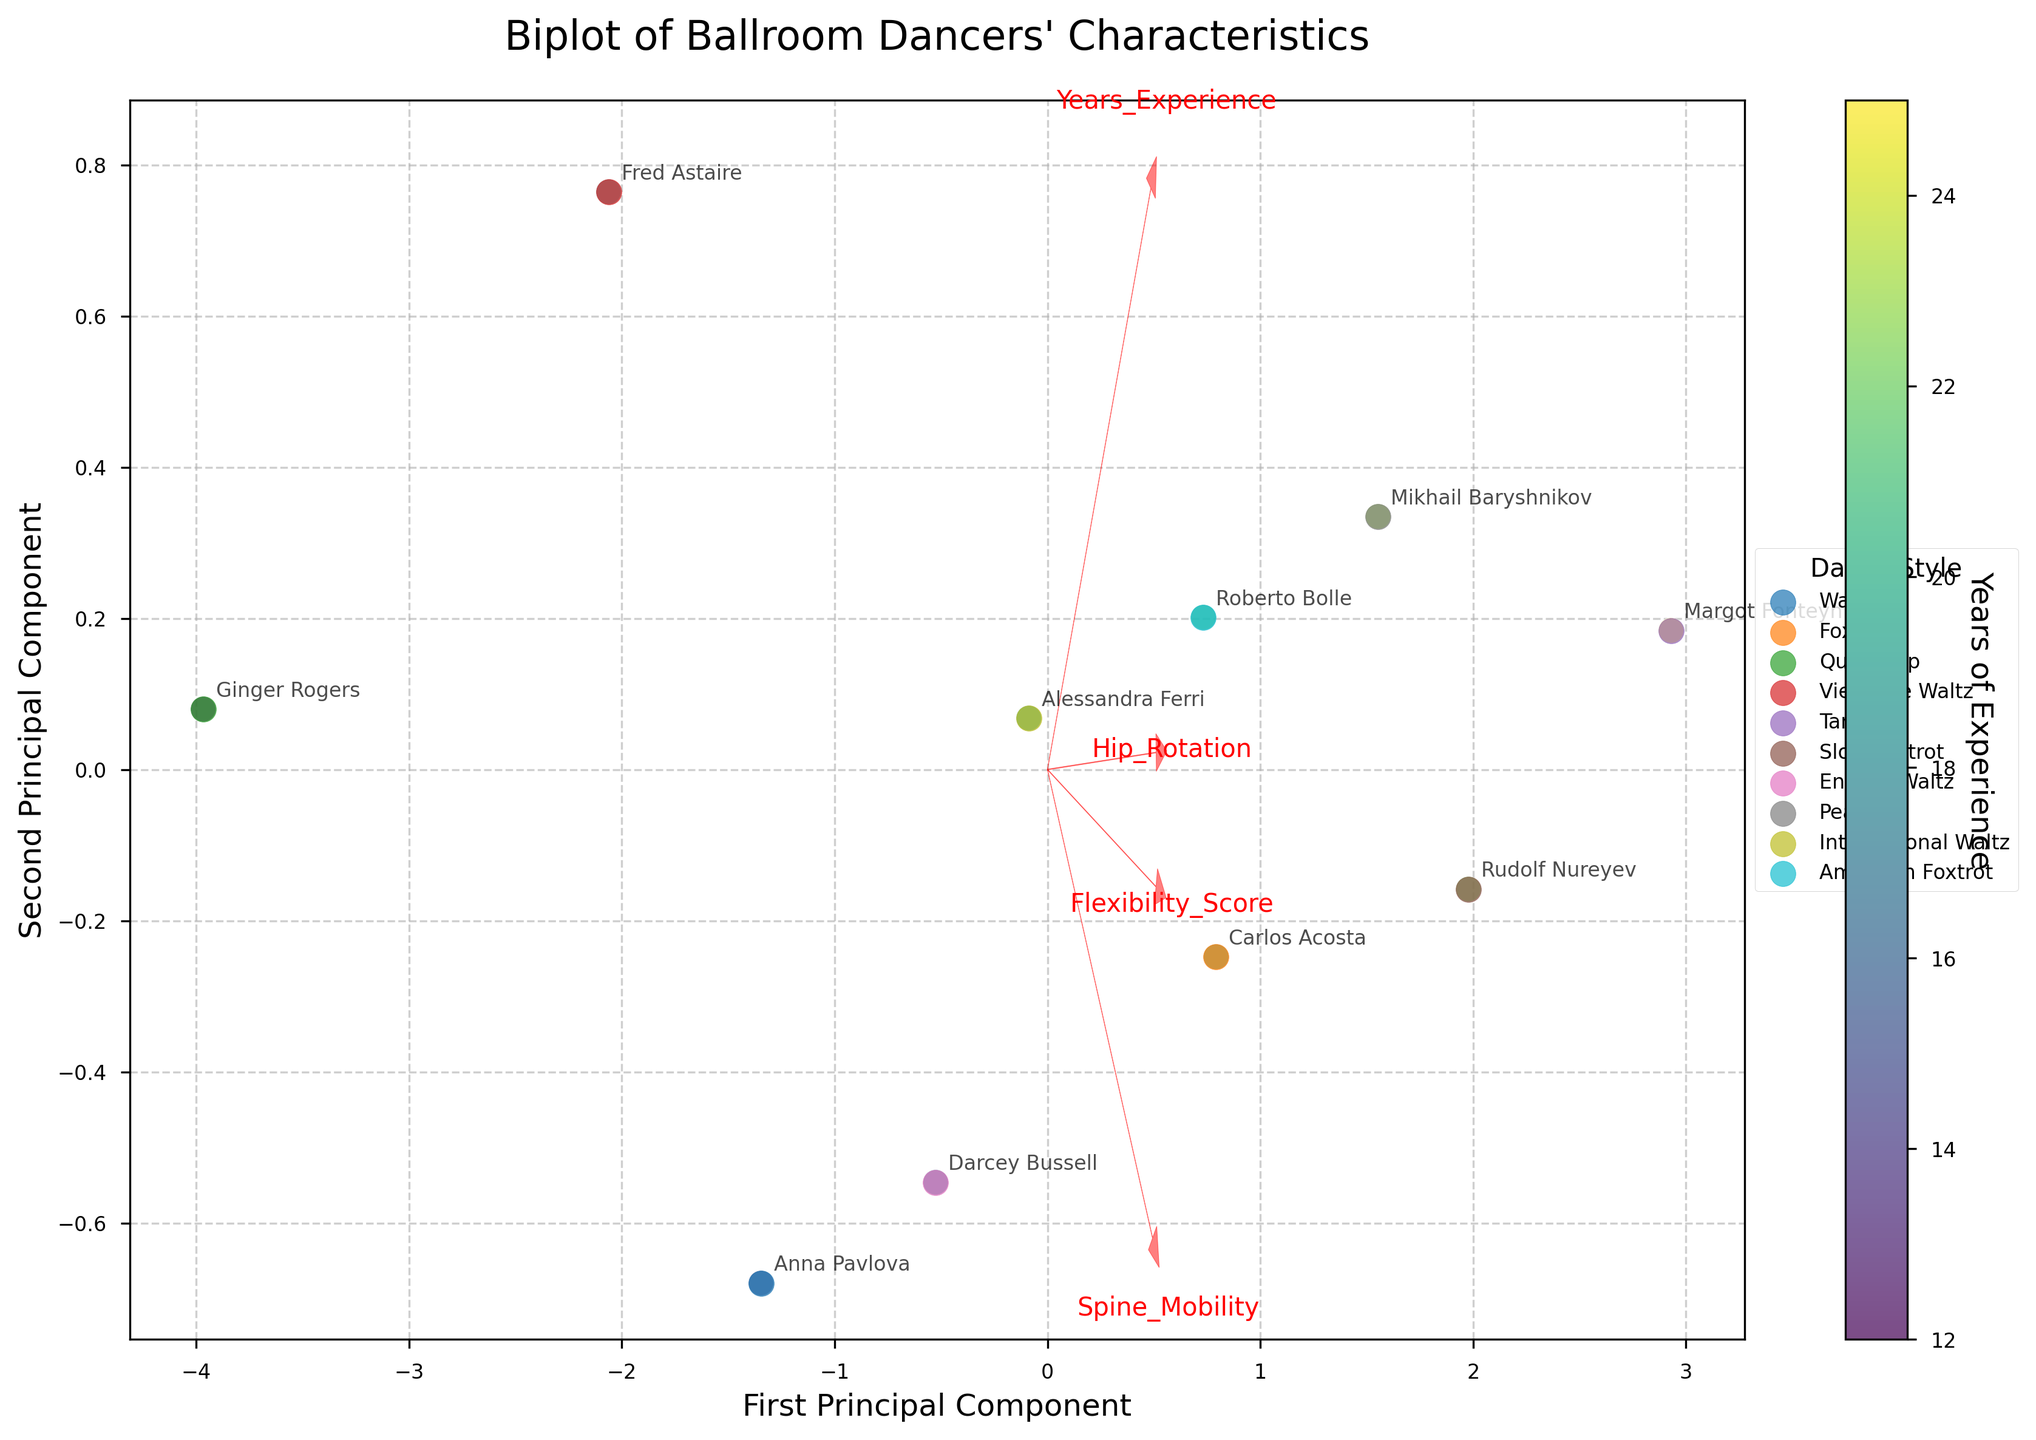How many dance styles are represented in the biplot? The legend on the right side of the biplot shows unique labels for dance styles. By counting these unique labels, we can determine the number of dance styles represented.
Answer: 10 What does the color of the scatter points represent? The colorbar label indicates that the colors represent the "Years of Experience" of the dancers.
Answer: Years of Experience Which principal component axis explains more variance? The x-axis is labeled as "First Principal Component," and this suggests it explains more variance compared to the "Second Principal Component" on the y-axis.
Answer: First Principal Component Whose flexibility score is plotted highest along the first principal component? The annotations near the highest point on the x-axis (First Principal Component) should identify the dancer.
Answer: Margot Fonteyn What do the red arrows represent in the biplot? The arrows are labeled with features such as "Years_Experience," "Flexibility_Score," "Hip_Rotation," and "Spine_Mobility;" they show the direction and importance of these features on the principal components.
Answer: Feature Vectors Which dancer has the least experience but a high flexibility score? Check the points with the darkest color representing the least years of experience and identify the corresponding annotation nearest to a high location on the y-axis (Second Principal Component).
Answer: Ginger Rogers Which feature seems to have the greatest influence on the second principal component? By looking at the directions and magnitudes of the red arrows, the arrow most aligned with the y-axis (Second Principal Component) indicates the feature with the greatest influence.
Answer: Flexibility_Score Are there any dancers with similar years of experience but differing flexibility scores? Compare the positions of similarly colored scatter points along the y-axis (Second Principal Component).
Answer: Yes, for instance, Fred Astaire and Darcey Bussell How does the dancer with the longest years of experience compare in flexibility and spine mobility? Locate the dancer with the darkest color indicating the longest experience and note their relative position in relation to the arrows "Flexibility_Score" and "Spine_Mobility."
Answer: Margot Fonteyn, High in both What is the general trend of years of experience relative to the first principal component? Examine the color gradient along the x-axis representing the First Principal Component; observe the general direction of the scatter points' colors.
Answer: Positive trend 